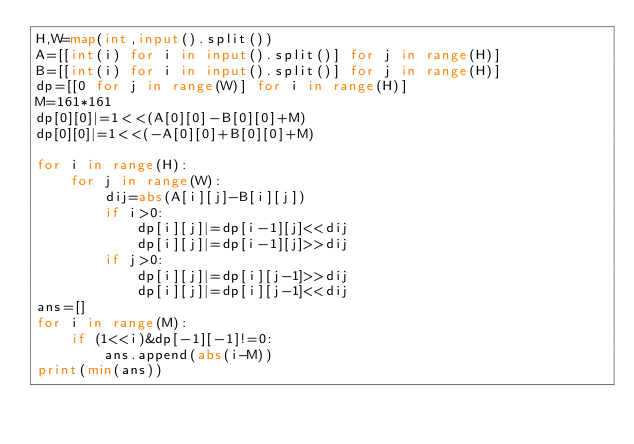Convert code to text. <code><loc_0><loc_0><loc_500><loc_500><_Python_>H,W=map(int,input().split())
A=[[int(i) for i in input().split()] for j in range(H)]
B=[[int(i) for i in input().split()] for j in range(H)]
dp=[[0 for j in range(W)] for i in range(H)]
M=161*161
dp[0][0]|=1<<(A[0][0]-B[0][0]+M)
dp[0][0]|=1<<(-A[0][0]+B[0][0]+M)

for i in range(H):
    for j in range(W):
        dij=abs(A[i][j]-B[i][j])
        if i>0:
            dp[i][j]|=dp[i-1][j]<<dij
            dp[i][j]|=dp[i-1][j]>>dij
        if j>0:
            dp[i][j]|=dp[i][j-1]>>dij
            dp[i][j]|=dp[i][j-1]<<dij
ans=[]
for i in range(M):
    if (1<<i)&dp[-1][-1]!=0:
        ans.append(abs(i-M))
print(min(ans))
</code> 